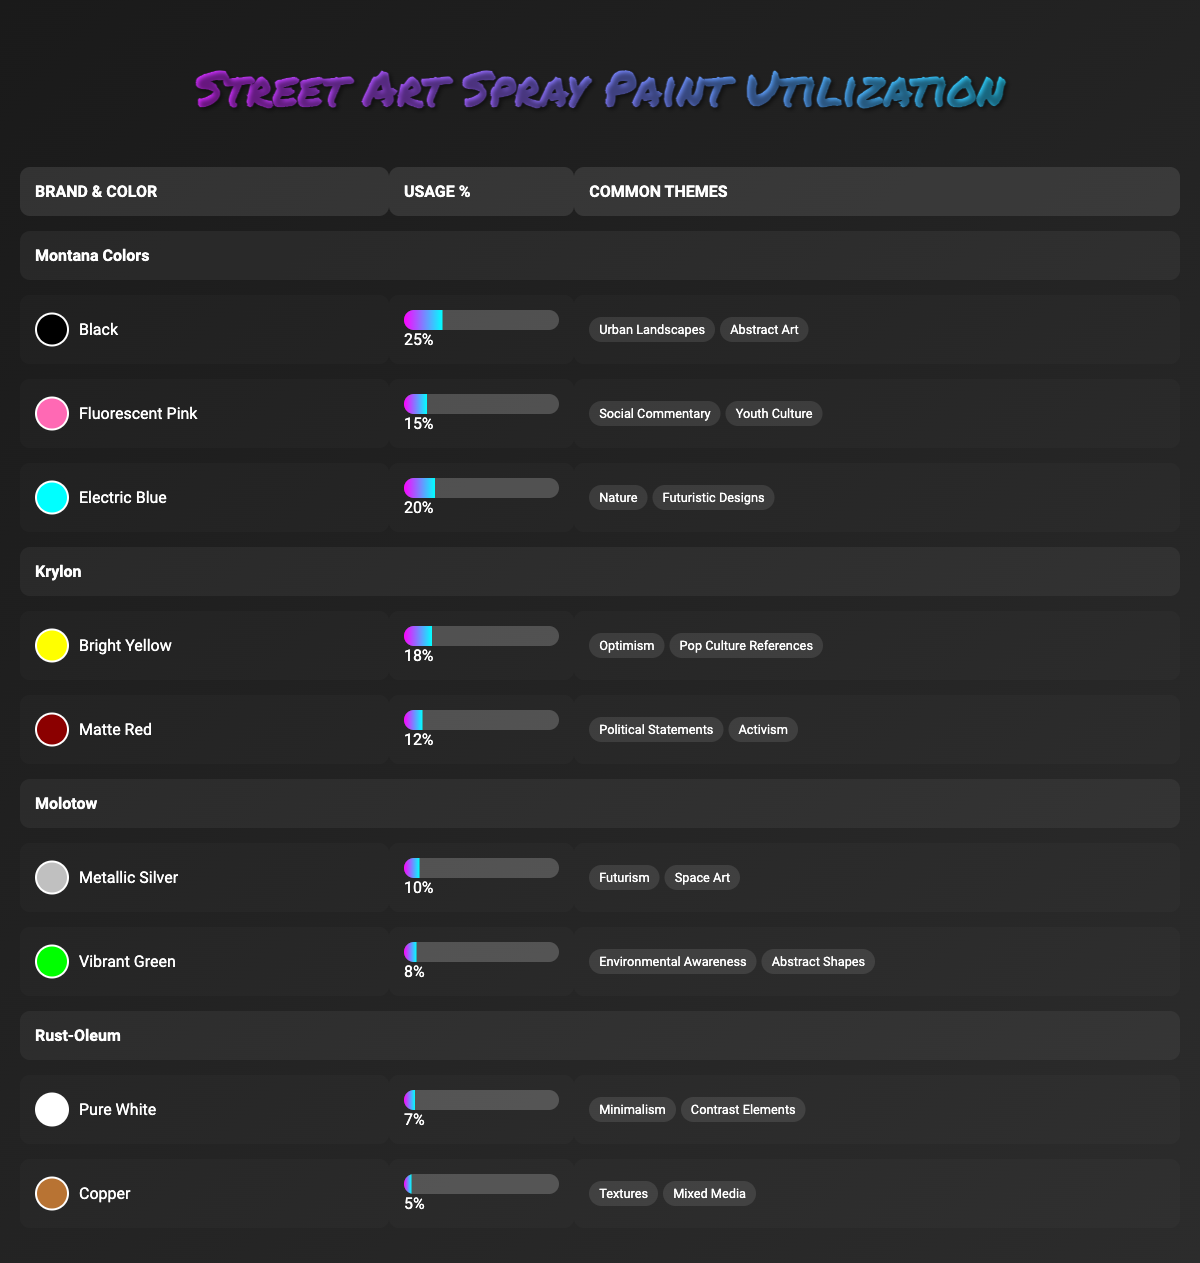What is the most used color from Montana Colors? In the Montana Colors section, I look at the usage percentages of the color variants. The color Black has the highest usage percentage at 25%.
Answer: Black Which brand has a color associated with "Political Statements"? By examining the table, I see that Matte Red from the Krylon brand is listed under Common Themes, specifically associated with "Political Statements."
Answer: Krylon What is the total usage percentage of colors from Rust-Oleum? The usage percentages for Rust-Oleum are 7% for Pure White and 5% for Copper. Adding these gives a total of 7 + 5 = 12%.
Answer: 12% Is Electric Blue more popular than Bright Yellow? Electric Blue from Montana Colors has a usage percentage of 20%, while Bright Yellow from Krylon has 18%. Since 20% is greater than 18%, Electric Blue is indeed more popular.
Answer: Yes Which brand has the highest single color usage percentage? Comparing all the highest usage percentages across brands, Montana Colors has Black at 25%, which is the highest compared to other colors listed from different brands. Therefore, Montana Colors has the highest single color usage percentage.
Answer: Montana Colors What is the average usage percentage of all color variants from Krylon? Krylon has two colors: Bright Yellow at 18% and Matte Red at 12%. To find the average, I add them up (18 + 12) = 30% and divide by 2, resulting in an average of 15%.
Answer: 15% Is it true that all color variants from Molotow are associated with environmental themes? Upon reviewing the Common Themes for Molotow's colors, Metallic Silver is associated with "Futurism" and "Space Art," while Vibrant Green is linked to "Environmental Awareness" and "Abstract Shapes." Since not all variants are related to environmental themes, the statement is false.
Answer: No What percentage of colors from Montana Colors are used for "Social Commentary"? Looking under Montana Colors, Fluorescent Pink, which has a usage percentage of 15%, is the only color associated with "Social Commentary." Therefore, the percentage for that theme is 15%.
Answer: 15% 